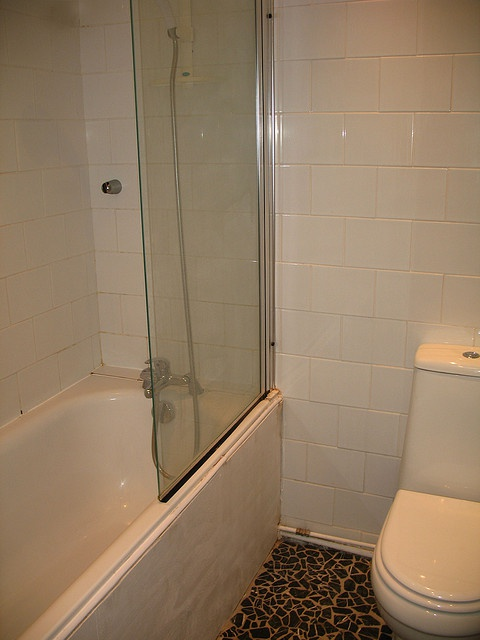Describe the objects in this image and their specific colors. I can see a toilet in black, tan, and gray tones in this image. 